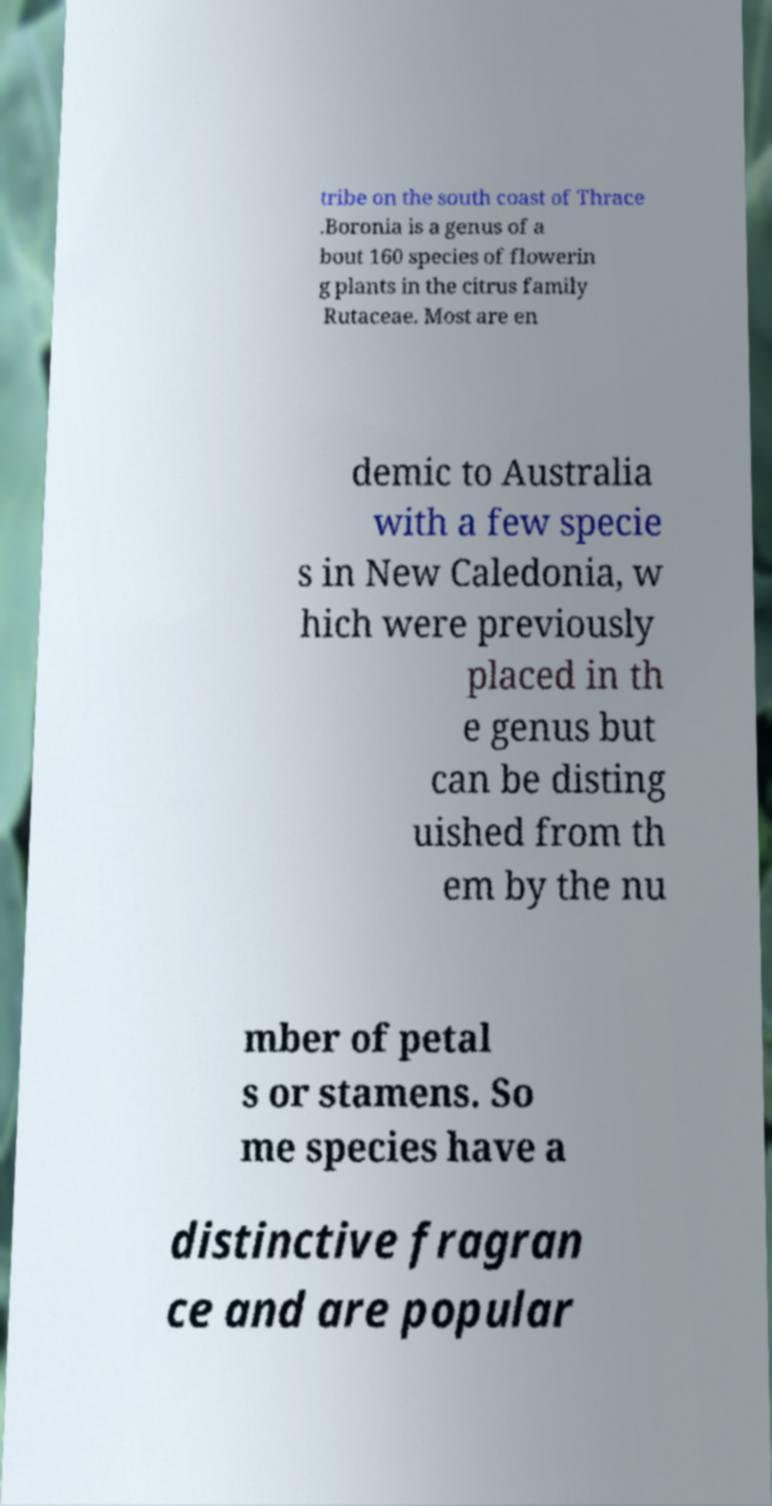What messages or text are displayed in this image? I need them in a readable, typed format. tribe on the south coast of Thrace .Boronia is a genus of a bout 160 species of flowerin g plants in the citrus family Rutaceae. Most are en demic to Australia with a few specie s in New Caledonia, w hich were previously placed in th e genus but can be disting uished from th em by the nu mber of petal s or stamens. So me species have a distinctive fragran ce and are popular 